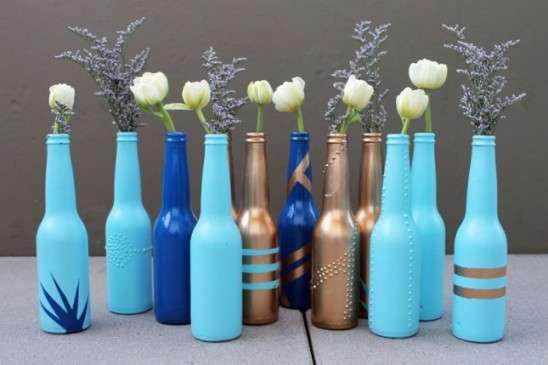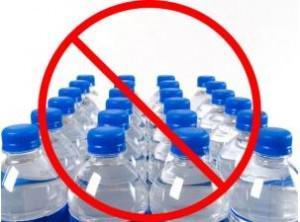The first image is the image on the left, the second image is the image on the right. For the images displayed, is the sentence "The right image depicts refillable sport-type water bottles." factually correct? Answer yes or no. No. The first image is the image on the left, the second image is the image on the right. Analyze the images presented: Is the assertion "One image is of many rows of plastic water bottles with plastic caps." valid? Answer yes or no. Yes. 